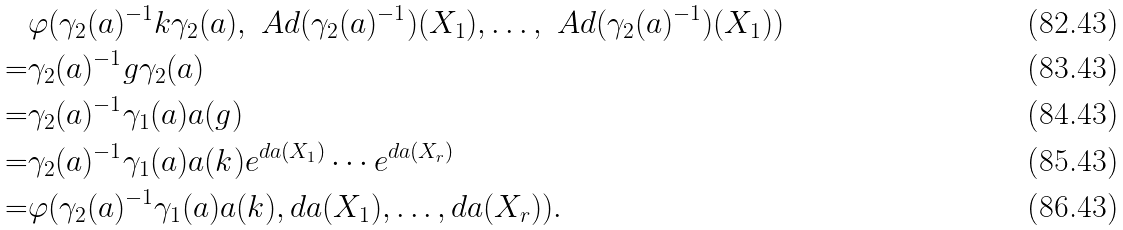Convert formula to latex. <formula><loc_0><loc_0><loc_500><loc_500>& \varphi ( \gamma _ { 2 } ( a ) ^ { - 1 } k \gamma _ { 2 } ( a ) , \ A d ( \gamma _ { 2 } ( a ) ^ { - 1 } ) ( X _ { 1 } ) , \dots , \ A d ( \gamma _ { 2 } ( a ) ^ { - 1 } ) ( X _ { 1 } ) ) \\ = & \gamma _ { 2 } ( a ) ^ { - 1 } g \gamma _ { 2 } ( a ) \\ = & \gamma _ { 2 } ( a ) ^ { - 1 } \gamma _ { 1 } ( a ) a ( g ) \\ = & \gamma _ { 2 } ( a ) ^ { - 1 } \gamma _ { 1 } ( a ) a ( k ) e ^ { d a ( X _ { 1 } ) } \cdots e ^ { d a ( X _ { r } ) } \\ = & \varphi ( \gamma _ { 2 } ( a ) ^ { - 1 } \gamma _ { 1 } ( a ) a ( k ) , d a ( X _ { 1 } ) , \dots , d a ( X _ { r } ) ) .</formula> 